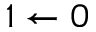Convert formula to latex. <formula><loc_0><loc_0><loc_500><loc_500>{ 1 \leftarrow 0 }</formula> 